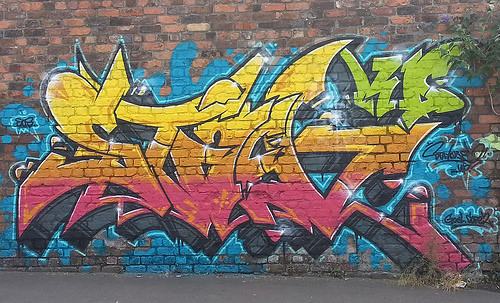<image>
Is the graffiti in front of the brick wall? Yes. The graffiti is positioned in front of the brick wall, appearing closer to the camera viewpoint. 